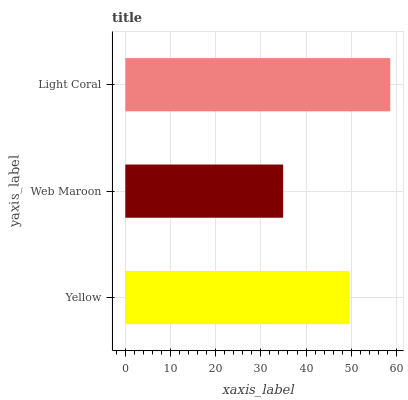Is Web Maroon the minimum?
Answer yes or no. Yes. Is Light Coral the maximum?
Answer yes or no. Yes. Is Light Coral the minimum?
Answer yes or no. No. Is Web Maroon the maximum?
Answer yes or no. No. Is Light Coral greater than Web Maroon?
Answer yes or no. Yes. Is Web Maroon less than Light Coral?
Answer yes or no. Yes. Is Web Maroon greater than Light Coral?
Answer yes or no. No. Is Light Coral less than Web Maroon?
Answer yes or no. No. Is Yellow the high median?
Answer yes or no. Yes. Is Yellow the low median?
Answer yes or no. Yes. Is Web Maroon the high median?
Answer yes or no. No. Is Light Coral the low median?
Answer yes or no. No. 